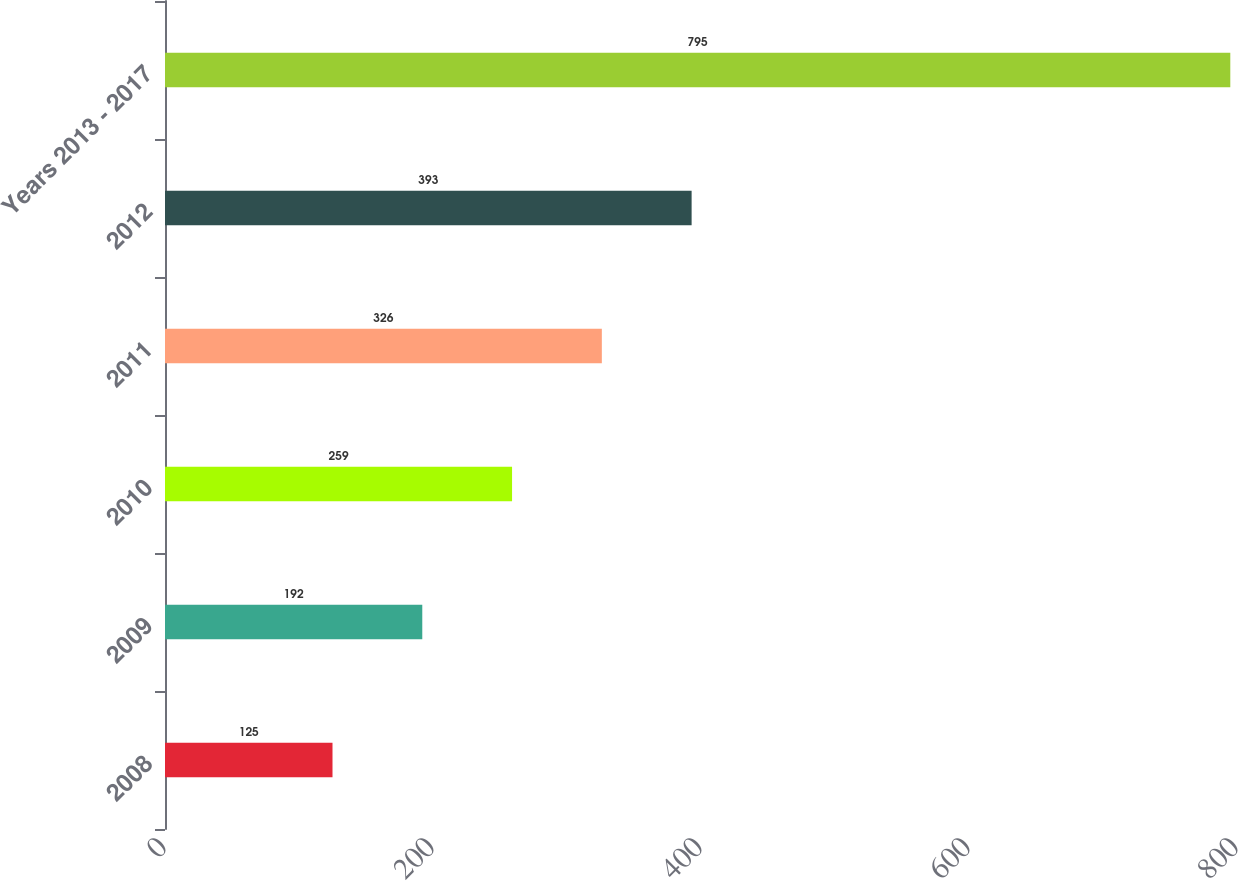<chart> <loc_0><loc_0><loc_500><loc_500><bar_chart><fcel>2008<fcel>2009<fcel>2010<fcel>2011<fcel>2012<fcel>Years 2013 - 2017<nl><fcel>125<fcel>192<fcel>259<fcel>326<fcel>393<fcel>795<nl></chart> 